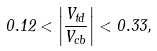Convert formula to latex. <formula><loc_0><loc_0><loc_500><loc_500>0 . 1 2 < \left | \frac { V _ { t d } } { V _ { c b } } \right | < 0 . 3 3 ,</formula> 